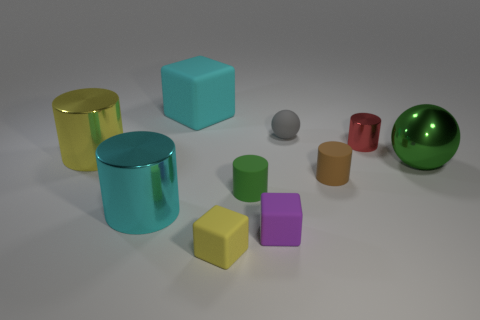Subtract 2 cubes. How many cubes are left? 1 Subtract all small green matte cylinders. How many cylinders are left? 4 Subtract all spheres. How many objects are left? 8 Subtract all blue cubes. How many cyan cylinders are left? 1 Subtract all red objects. Subtract all small rubber balls. How many objects are left? 8 Add 8 big balls. How many big balls are left? 9 Add 3 gray objects. How many gray objects exist? 4 Subtract all green balls. How many balls are left? 1 Subtract 1 cyan cubes. How many objects are left? 9 Subtract all purple cylinders. Subtract all yellow cubes. How many cylinders are left? 5 